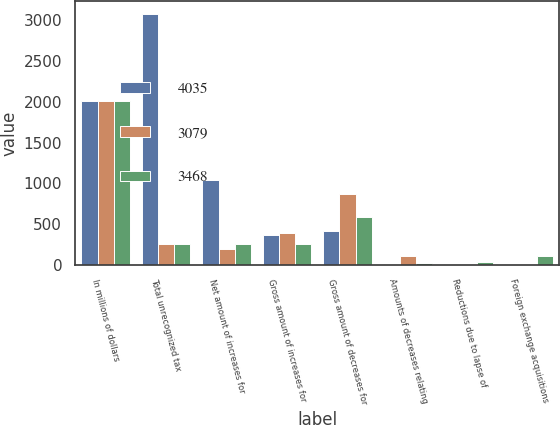Convert chart. <chart><loc_0><loc_0><loc_500><loc_500><stacked_bar_chart><ecel><fcel>In millions of dollars<fcel>Total unrecognized tax<fcel>Net amount of increases for<fcel>Gross amount of increases for<fcel>Gross amount of decreases for<fcel>Amounts of decreases relating<fcel>Reductions due to lapse of<fcel>Foreign exchange acquisitions<nl><fcel>4035<fcel>2010<fcel>3079<fcel>1039<fcel>371<fcel>421<fcel>14<fcel>11<fcel>8<nl><fcel>3079<fcel>2009<fcel>253<fcel>195<fcel>392<fcel>870<fcel>104<fcel>12<fcel>10<nl><fcel>3468<fcel>2008<fcel>253<fcel>254<fcel>252<fcel>581<fcel>21<fcel>30<fcel>104<nl></chart> 